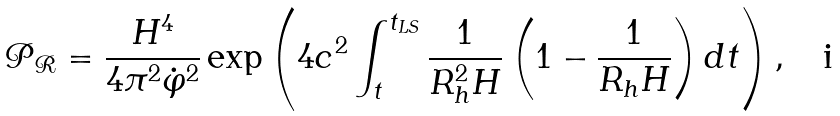<formula> <loc_0><loc_0><loc_500><loc_500>\mathcal { P } _ { \mathcal { R } } = \frac { H ^ { 4 } } { 4 \pi ^ { 2 } \dot { \varphi } ^ { 2 } } \exp \left ( 4 c ^ { 2 } \int _ { t } ^ { t _ { L S } } \frac { 1 } { R _ { h } ^ { 2 } H } \left ( 1 - \frac { 1 } { R _ { h } H } \right ) d t \right ) ,</formula> 